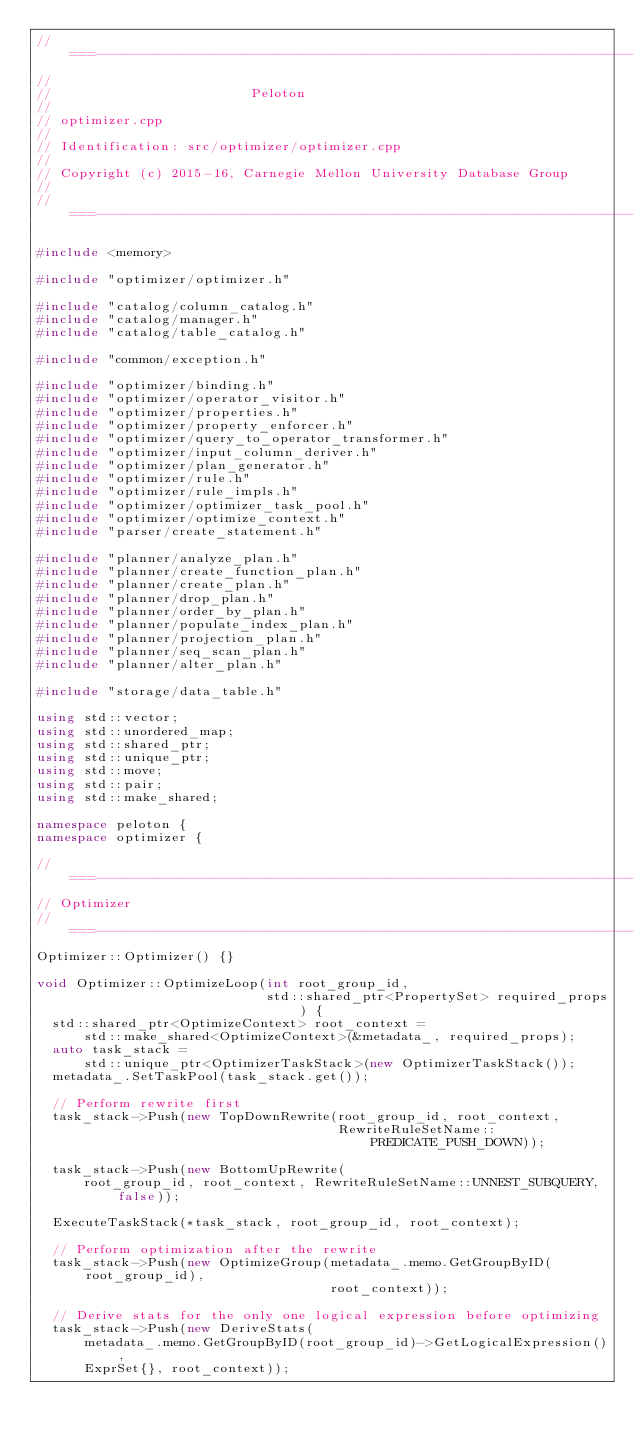<code> <loc_0><loc_0><loc_500><loc_500><_C++_>//===----------------------------------------------------------------------===//
//
//                         Peloton
//
// optimizer.cpp
//
// Identification: src/optimizer/optimizer.cpp
//
// Copyright (c) 2015-16, Carnegie Mellon University Database Group
//
//===----------------------------------------------------------------------===//

#include <memory>

#include "optimizer/optimizer.h"

#include "catalog/column_catalog.h"
#include "catalog/manager.h"
#include "catalog/table_catalog.h"

#include "common/exception.h"

#include "optimizer/binding.h"
#include "optimizer/operator_visitor.h"
#include "optimizer/properties.h"
#include "optimizer/property_enforcer.h"
#include "optimizer/query_to_operator_transformer.h"
#include "optimizer/input_column_deriver.h"
#include "optimizer/plan_generator.h"
#include "optimizer/rule.h"
#include "optimizer/rule_impls.h"
#include "optimizer/optimizer_task_pool.h"
#include "optimizer/optimize_context.h"
#include "parser/create_statement.h"

#include "planner/analyze_plan.h"
#include "planner/create_function_plan.h"
#include "planner/create_plan.h"
#include "planner/drop_plan.h"
#include "planner/order_by_plan.h"
#include "planner/populate_index_plan.h"
#include "planner/projection_plan.h"
#include "planner/seq_scan_plan.h"
#include "planner/alter_plan.h"

#include "storage/data_table.h"

using std::vector;
using std::unordered_map;
using std::shared_ptr;
using std::unique_ptr;
using std::move;
using std::pair;
using std::make_shared;

namespace peloton {
namespace optimizer {

//===--------------------------------------------------------------------===//
// Optimizer
//===--------------------------------------------------------------------===//
Optimizer::Optimizer() {}

void Optimizer::OptimizeLoop(int root_group_id,
                             std::shared_ptr<PropertySet> required_props) {
  std::shared_ptr<OptimizeContext> root_context =
      std::make_shared<OptimizeContext>(&metadata_, required_props);
  auto task_stack =
      std::unique_ptr<OptimizerTaskStack>(new OptimizerTaskStack());
  metadata_.SetTaskPool(task_stack.get());

  // Perform rewrite first
  task_stack->Push(new TopDownRewrite(root_group_id, root_context,
                                      RewriteRuleSetName::PREDICATE_PUSH_DOWN));

  task_stack->Push(new BottomUpRewrite(
      root_group_id, root_context, RewriteRuleSetName::UNNEST_SUBQUERY, false));

  ExecuteTaskStack(*task_stack, root_group_id, root_context);

  // Perform optimization after the rewrite
  task_stack->Push(new OptimizeGroup(metadata_.memo.GetGroupByID(root_group_id),
                                     root_context));

  // Derive stats for the only one logical expression before optimizing
  task_stack->Push(new DeriveStats(
      metadata_.memo.GetGroupByID(root_group_id)->GetLogicalExpression(),
      ExprSet{}, root_context));
</code> 